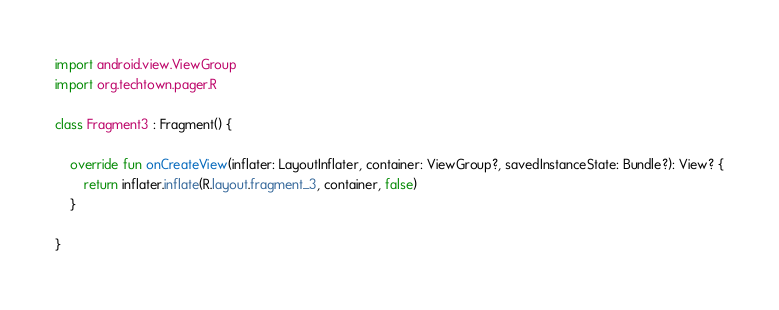Convert code to text. <code><loc_0><loc_0><loc_500><loc_500><_Kotlin_>import android.view.ViewGroup
import org.techtown.pager.R

class Fragment3 : Fragment() {

    override fun onCreateView(inflater: LayoutInflater, container: ViewGroup?, savedInstanceState: Bundle?): View? {
        return inflater.inflate(R.layout.fragment_3, container, false)
    }
 
}</code> 